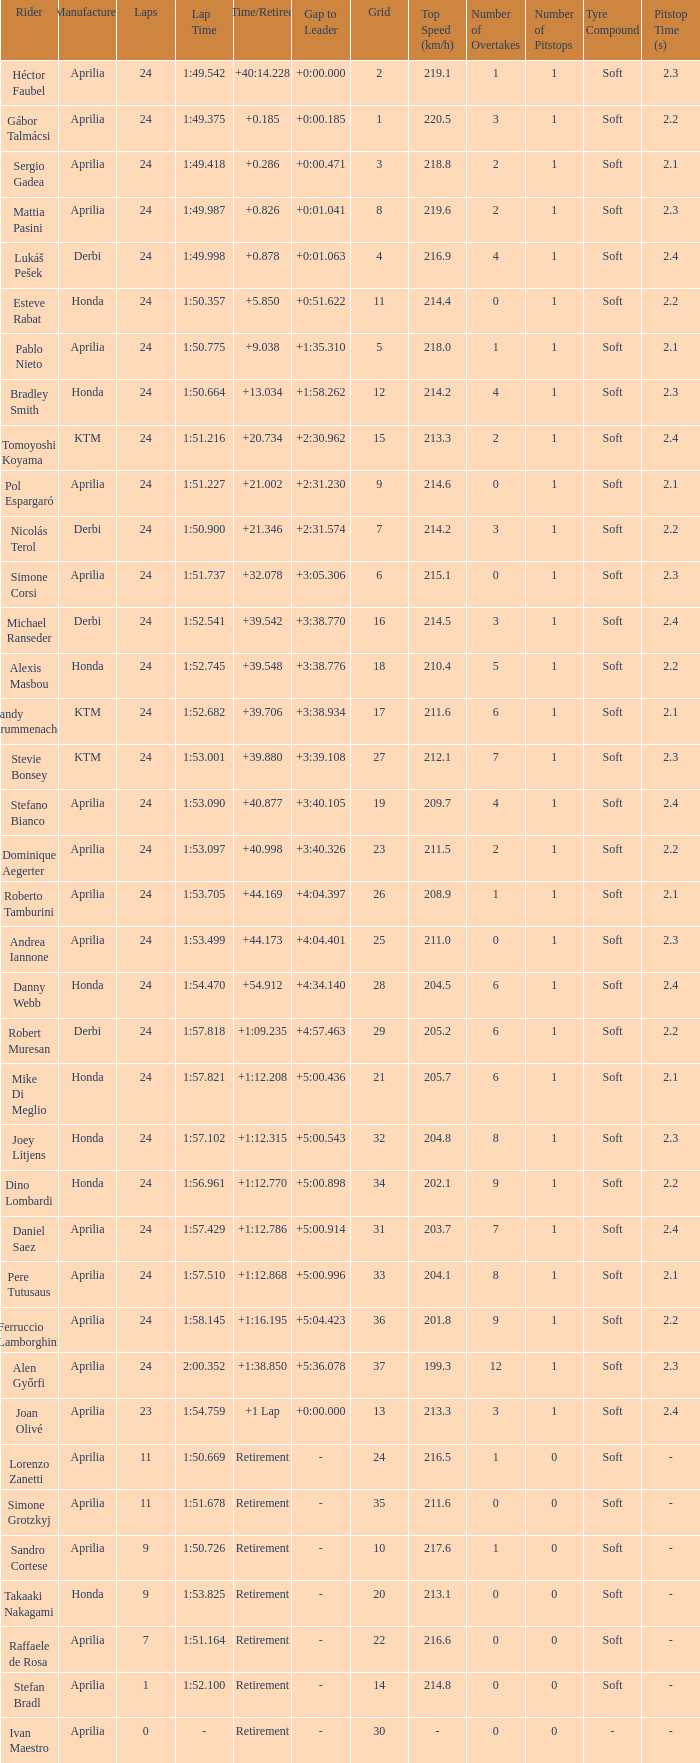How many grids have more than 24 laps with a time/retired of +1:12.208? None. 